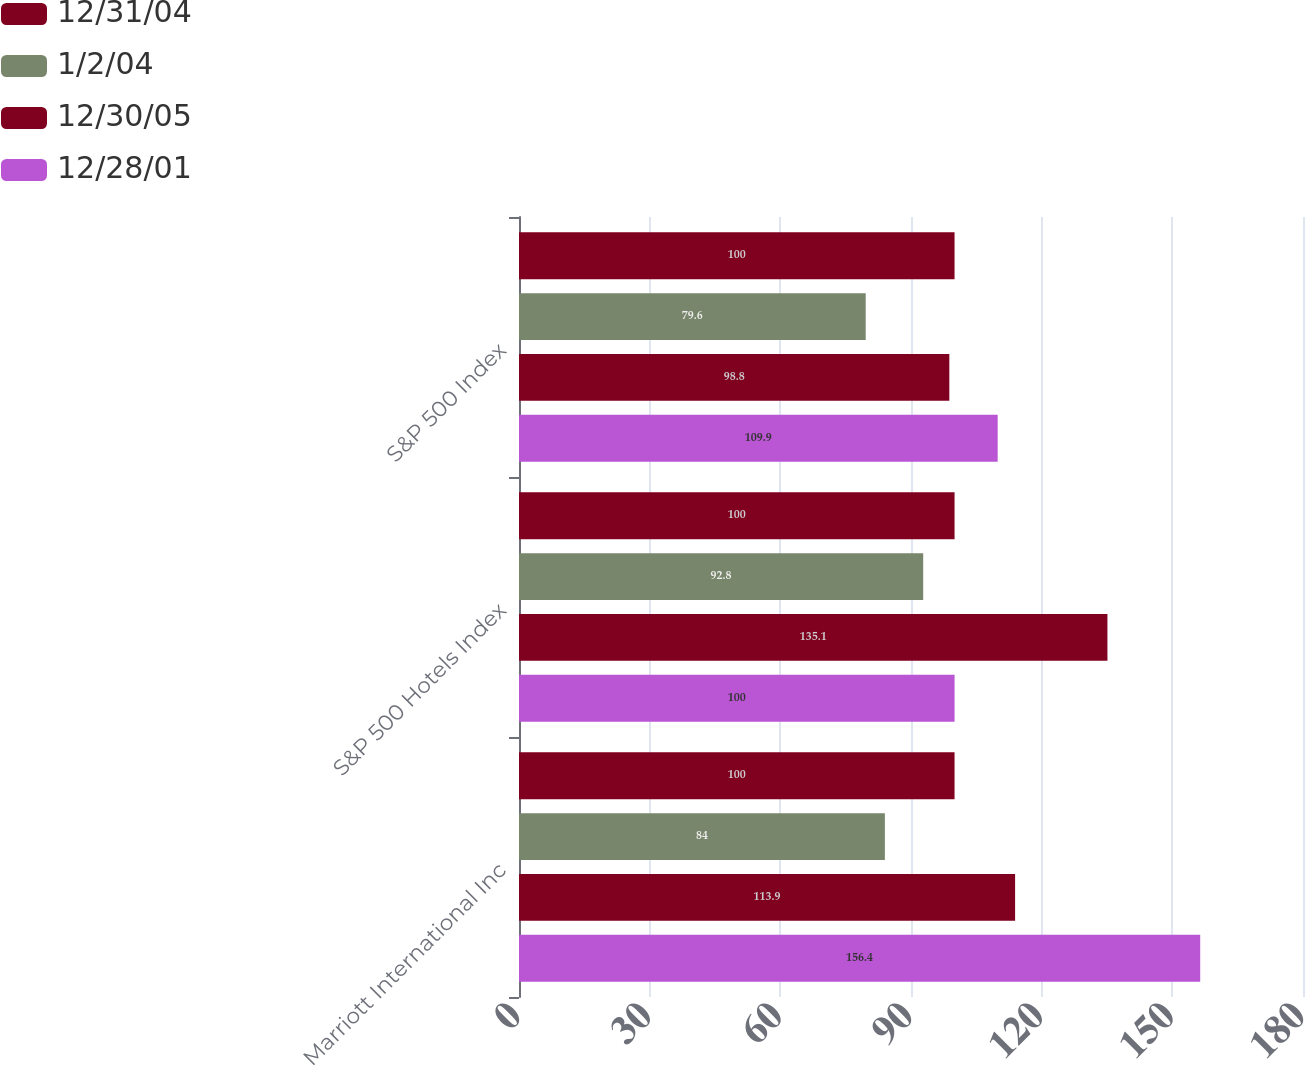<chart> <loc_0><loc_0><loc_500><loc_500><stacked_bar_chart><ecel><fcel>Marriott International Inc<fcel>S&P 500 Hotels Index<fcel>S&P 500 Index<nl><fcel>12/31/04<fcel>100<fcel>100<fcel>100<nl><fcel>1/2/04<fcel>84<fcel>92.8<fcel>79.6<nl><fcel>12/30/05<fcel>113.9<fcel>135.1<fcel>98.8<nl><fcel>12/28/01<fcel>156.4<fcel>100<fcel>109.9<nl></chart> 